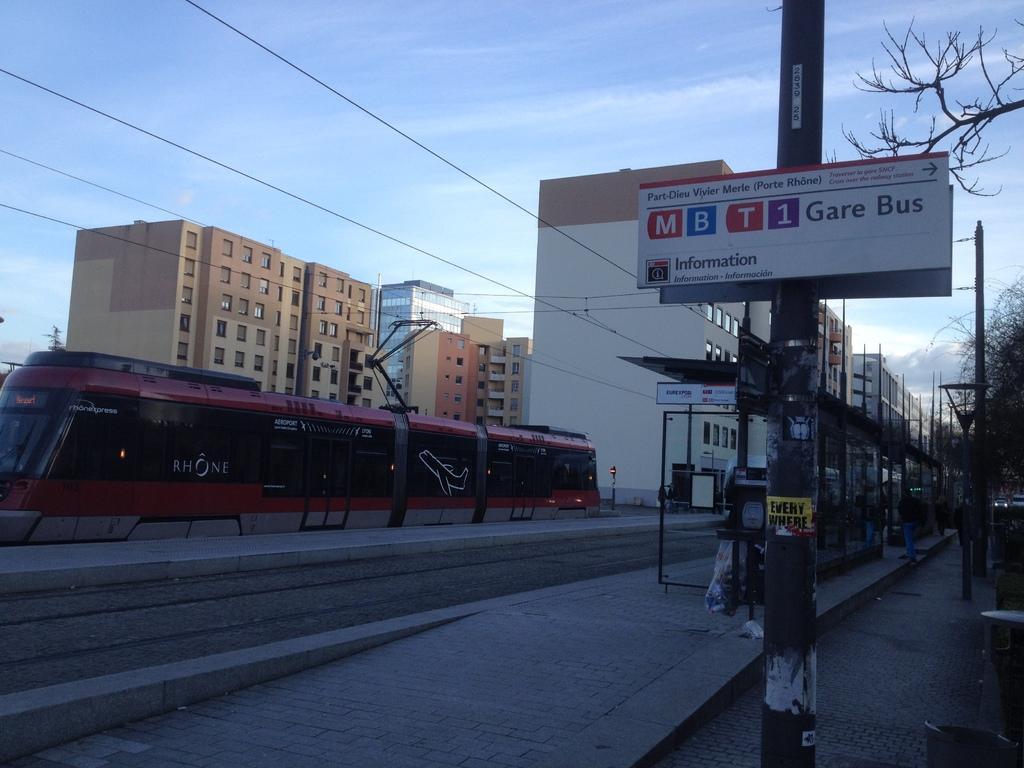In one or two sentences, can you explain what this image depicts? This is a platform where I can see a shed. on the the left side there is a vehicle which is in red color. In the background there are some buildings. On the right side, I can see few pillars and trees. On the top of the image I can see the sky and wires. 